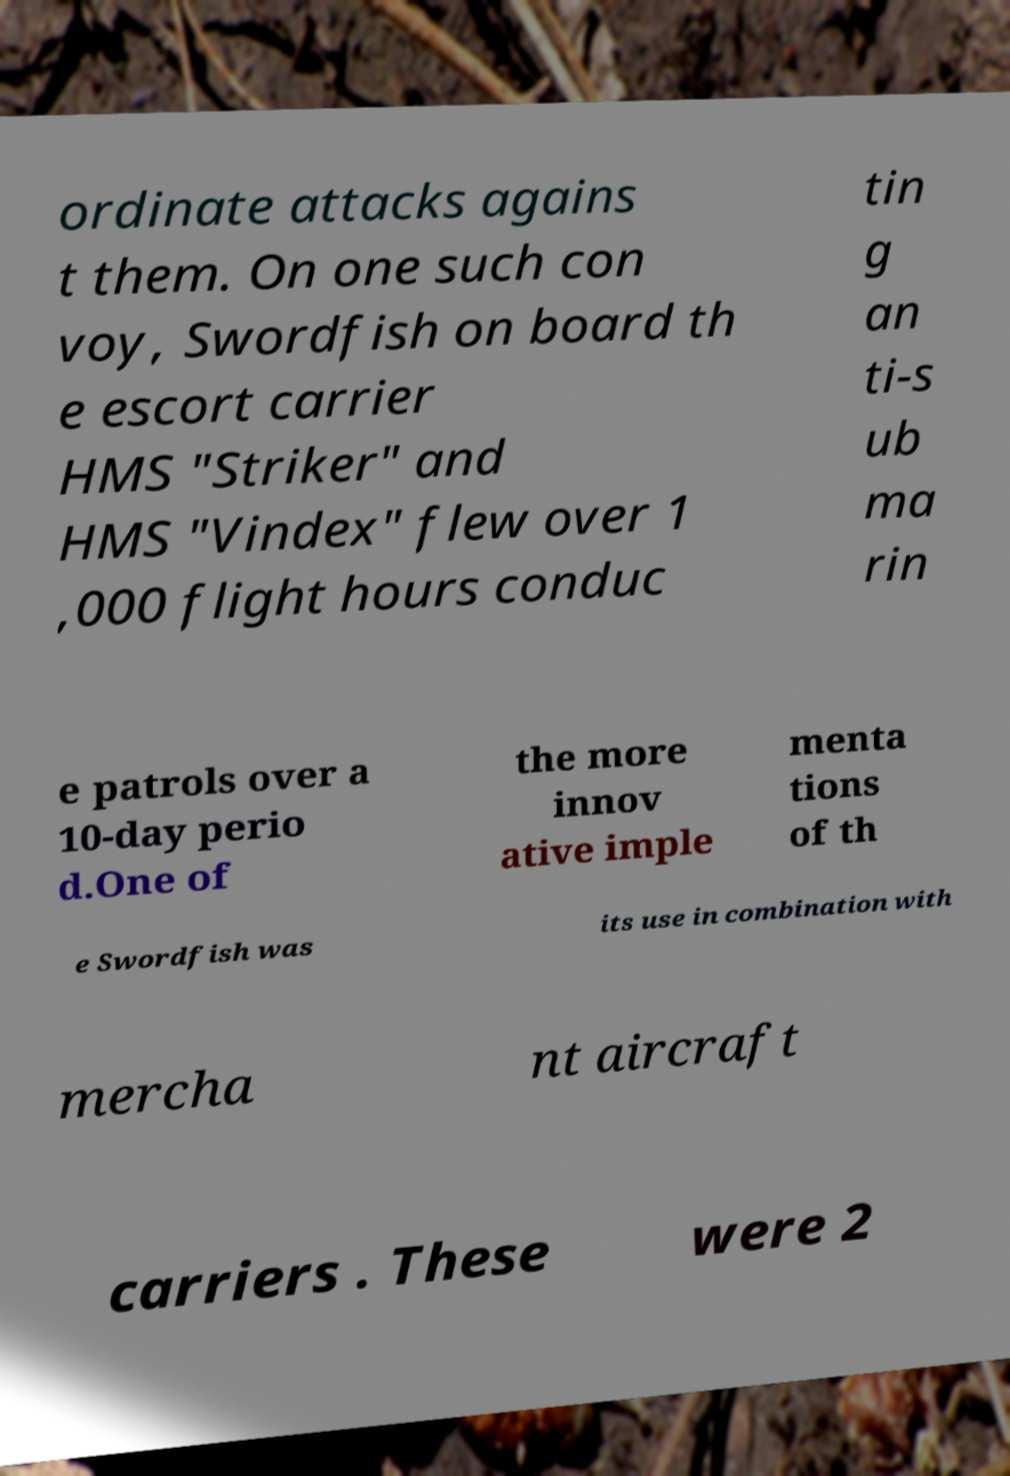Please read and relay the text visible in this image. What does it say? ordinate attacks agains t them. On one such con voy, Swordfish on board th e escort carrier HMS "Striker" and HMS "Vindex" flew over 1 ,000 flight hours conduc tin g an ti-s ub ma rin e patrols over a 10-day perio d.One of the more innov ative imple menta tions of th e Swordfish was its use in combination with mercha nt aircraft carriers . These were 2 